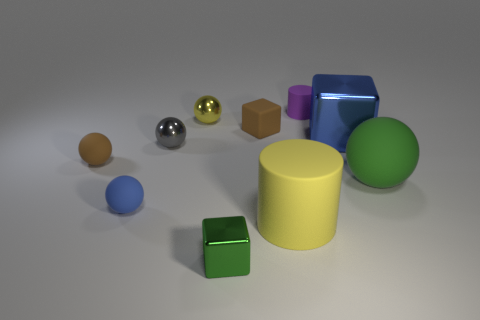Subtract all shiny spheres. How many spheres are left? 3 Subtract all purple cylinders. How many cylinders are left? 1 Subtract 2 blocks. How many blocks are left? 1 Add 2 large yellow rubber cylinders. How many large yellow rubber cylinders exist? 3 Subtract 0 gray cylinders. How many objects are left? 10 Subtract all blocks. How many objects are left? 7 Subtract all cyan cylinders. Subtract all purple balls. How many cylinders are left? 2 Subtract all brown cubes. How many brown balls are left? 1 Subtract all blue balls. Subtract all tiny purple cylinders. How many objects are left? 8 Add 7 big cubes. How many big cubes are left? 8 